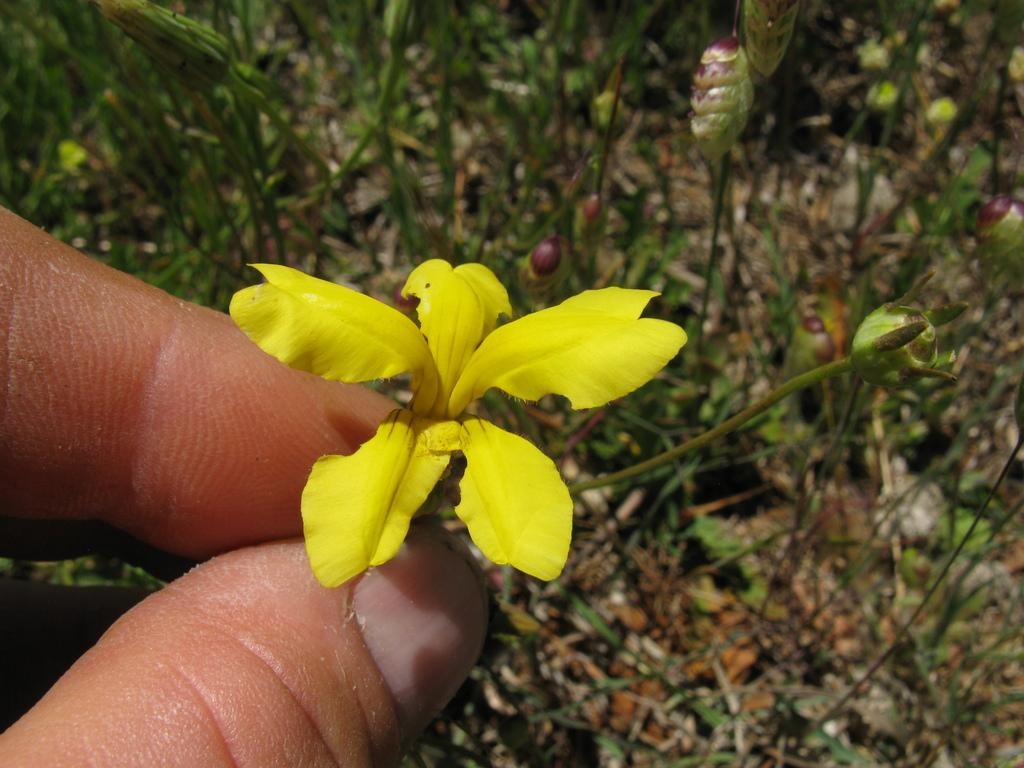Who is present in the image? There is a person in the image. What is the person holding in the image? The person is holding a yellow flower. What can be seen on the floor in the image? There are plants on the floor in the image. What is the current state of the plants in the image? The plants have flowers and buds. What type of vacation is the person planning based on the image? There is no information about a vacation in the image, as it only shows a person holding a yellow flower and plants on the floor. 